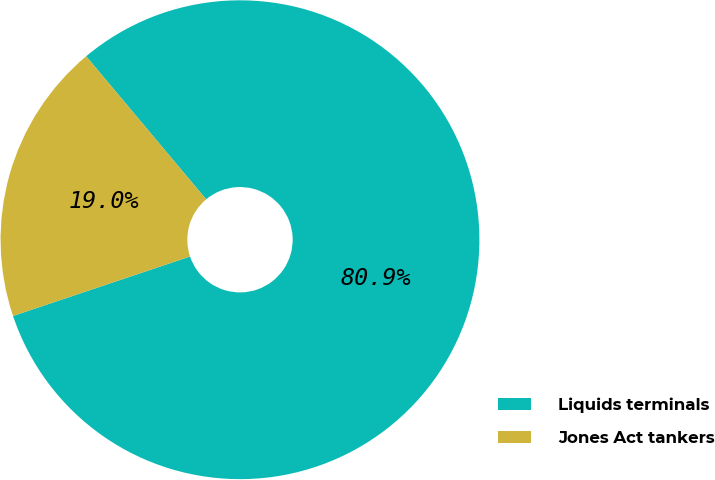Convert chart. <chart><loc_0><loc_0><loc_500><loc_500><pie_chart><fcel>Liquids terminals<fcel>Jones Act tankers<nl><fcel>80.95%<fcel>19.05%<nl></chart> 